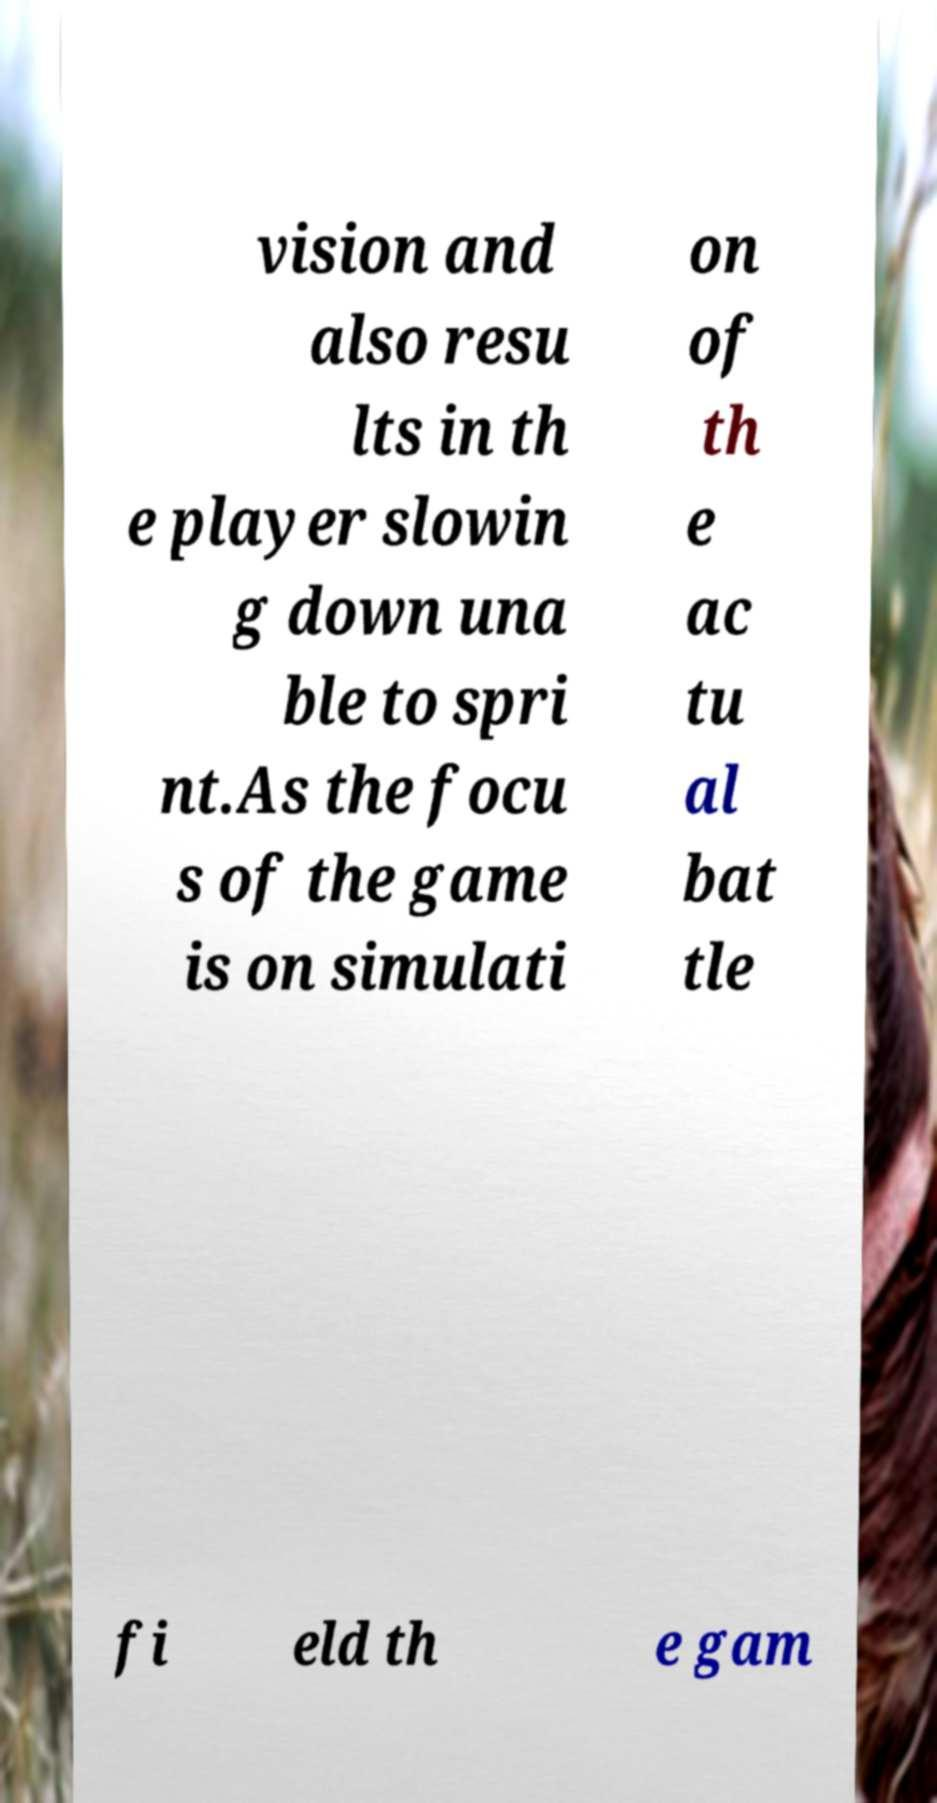What messages or text are displayed in this image? I need them in a readable, typed format. vision and also resu lts in th e player slowin g down una ble to spri nt.As the focu s of the game is on simulati on of th e ac tu al bat tle fi eld th e gam 